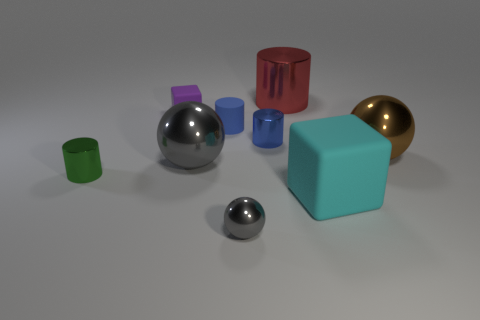There is a block that is in front of the brown metallic sphere; what is its size?
Provide a succinct answer. Large. How many tiny metal cylinders are on the right side of the small purple object left of the gray ball that is behind the small green cylinder?
Ensure brevity in your answer.  1. Is the color of the tiny shiny ball the same as the tiny cube?
Provide a succinct answer. No. What number of blocks are both behind the tiny blue rubber object and to the right of the small purple thing?
Your response must be concise. 0. What shape is the matte object that is on the right side of the big red metal thing?
Offer a terse response. Cube. Are there fewer blue rubber objects to the left of the red object than tiny blue matte cylinders in front of the green metallic thing?
Provide a short and direct response. No. Is the gray thing behind the small green shiny cylinder made of the same material as the block behind the green object?
Give a very brief answer. No. What shape is the small gray shiny object?
Offer a very short reply. Sphere. Is the number of tiny green objects that are to the right of the brown thing greater than the number of big gray objects that are right of the green object?
Provide a succinct answer. No. Do the shiny thing that is to the right of the big red metal cylinder and the large shiny object that is to the left of the small blue shiny cylinder have the same shape?
Give a very brief answer. Yes. 